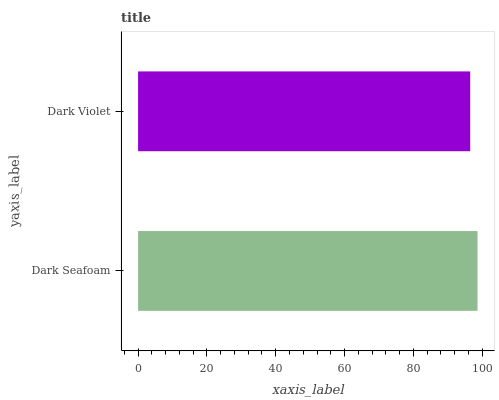Is Dark Violet the minimum?
Answer yes or no. Yes. Is Dark Seafoam the maximum?
Answer yes or no. Yes. Is Dark Violet the maximum?
Answer yes or no. No. Is Dark Seafoam greater than Dark Violet?
Answer yes or no. Yes. Is Dark Violet less than Dark Seafoam?
Answer yes or no. Yes. Is Dark Violet greater than Dark Seafoam?
Answer yes or no. No. Is Dark Seafoam less than Dark Violet?
Answer yes or no. No. Is Dark Seafoam the high median?
Answer yes or no. Yes. Is Dark Violet the low median?
Answer yes or no. Yes. Is Dark Violet the high median?
Answer yes or no. No. Is Dark Seafoam the low median?
Answer yes or no. No. 